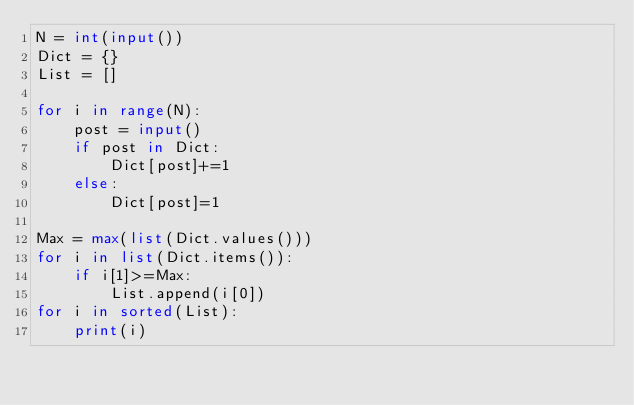Convert code to text. <code><loc_0><loc_0><loc_500><loc_500><_Python_>N = int(input())
Dict = {}
List = []

for i in range(N):
    post = input()
    if post in Dict:
        Dict[post]+=1
    else:
        Dict[post]=1

Max = max(list(Dict.values()))
for i in list(Dict.items()):
    if i[1]>=Max:
        List.append(i[0])
for i in sorted(List):
    print(i)</code> 